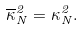Convert formula to latex. <formula><loc_0><loc_0><loc_500><loc_500>\overline { \kappa } _ { N } ^ { 2 } = \kappa _ { N } ^ { 2 } .</formula> 